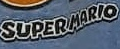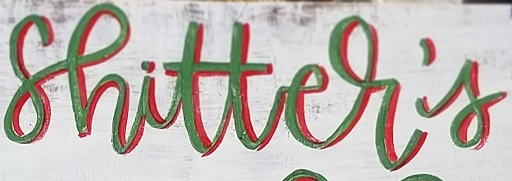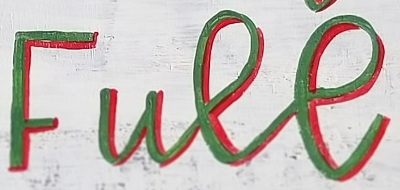Read the text content from these images in order, separated by a semicolon. SUPERMARIO; shitter's; Full 